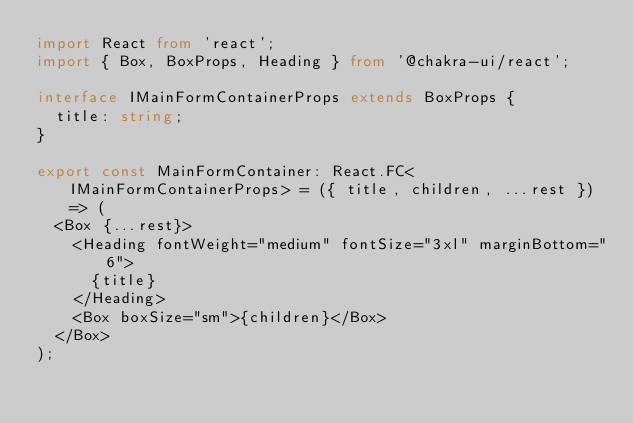<code> <loc_0><loc_0><loc_500><loc_500><_TypeScript_>import React from 'react';
import { Box, BoxProps, Heading } from '@chakra-ui/react';

interface IMainFormContainerProps extends BoxProps {
  title: string;
}

export const MainFormContainer: React.FC<IMainFormContainerProps> = ({ title, children, ...rest }) => (
  <Box {...rest}>
    <Heading fontWeight="medium" fontSize="3xl" marginBottom="6">
      {title}
    </Heading>
    <Box boxSize="sm">{children}</Box>
  </Box>
);
</code> 